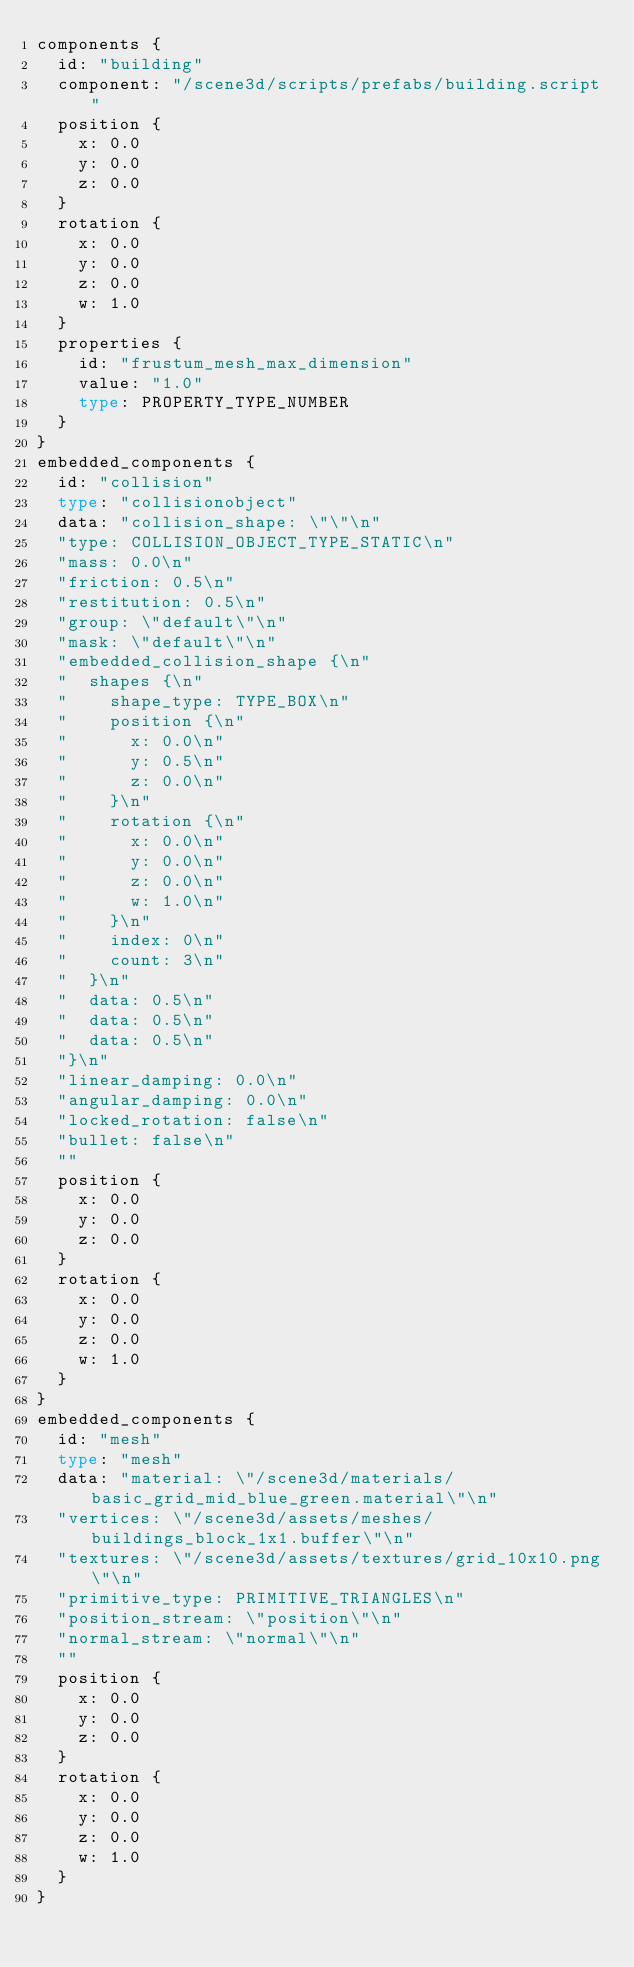<code> <loc_0><loc_0><loc_500><loc_500><_Go_>components {
  id: "building"
  component: "/scene3d/scripts/prefabs/building.script"
  position {
    x: 0.0
    y: 0.0
    z: 0.0
  }
  rotation {
    x: 0.0
    y: 0.0
    z: 0.0
    w: 1.0
  }
  properties {
    id: "frustum_mesh_max_dimension"
    value: "1.0"
    type: PROPERTY_TYPE_NUMBER
  }
}
embedded_components {
  id: "collision"
  type: "collisionobject"
  data: "collision_shape: \"\"\n"
  "type: COLLISION_OBJECT_TYPE_STATIC\n"
  "mass: 0.0\n"
  "friction: 0.5\n"
  "restitution: 0.5\n"
  "group: \"default\"\n"
  "mask: \"default\"\n"
  "embedded_collision_shape {\n"
  "  shapes {\n"
  "    shape_type: TYPE_BOX\n"
  "    position {\n"
  "      x: 0.0\n"
  "      y: 0.5\n"
  "      z: 0.0\n"
  "    }\n"
  "    rotation {\n"
  "      x: 0.0\n"
  "      y: 0.0\n"
  "      z: 0.0\n"
  "      w: 1.0\n"
  "    }\n"
  "    index: 0\n"
  "    count: 3\n"
  "  }\n"
  "  data: 0.5\n"
  "  data: 0.5\n"
  "  data: 0.5\n"
  "}\n"
  "linear_damping: 0.0\n"
  "angular_damping: 0.0\n"
  "locked_rotation: false\n"
  "bullet: false\n"
  ""
  position {
    x: 0.0
    y: 0.0
    z: 0.0
  }
  rotation {
    x: 0.0
    y: 0.0
    z: 0.0
    w: 1.0
  }
}
embedded_components {
  id: "mesh"
  type: "mesh"
  data: "material: \"/scene3d/materials/basic_grid_mid_blue_green.material\"\n"
  "vertices: \"/scene3d/assets/meshes/buildings_block_1x1.buffer\"\n"
  "textures: \"/scene3d/assets/textures/grid_10x10.png\"\n"
  "primitive_type: PRIMITIVE_TRIANGLES\n"
  "position_stream: \"position\"\n"
  "normal_stream: \"normal\"\n"
  ""
  position {
    x: 0.0
    y: 0.0
    z: 0.0
  }
  rotation {
    x: 0.0
    y: 0.0
    z: 0.0
    w: 1.0
  }
}
</code> 